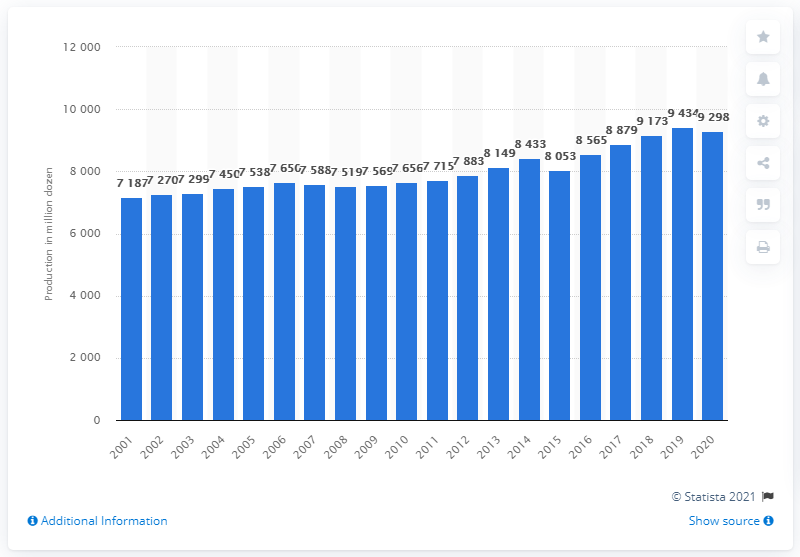Give some essential details in this illustration. In 2020, the United States produced approximately 92,980 eggs. 